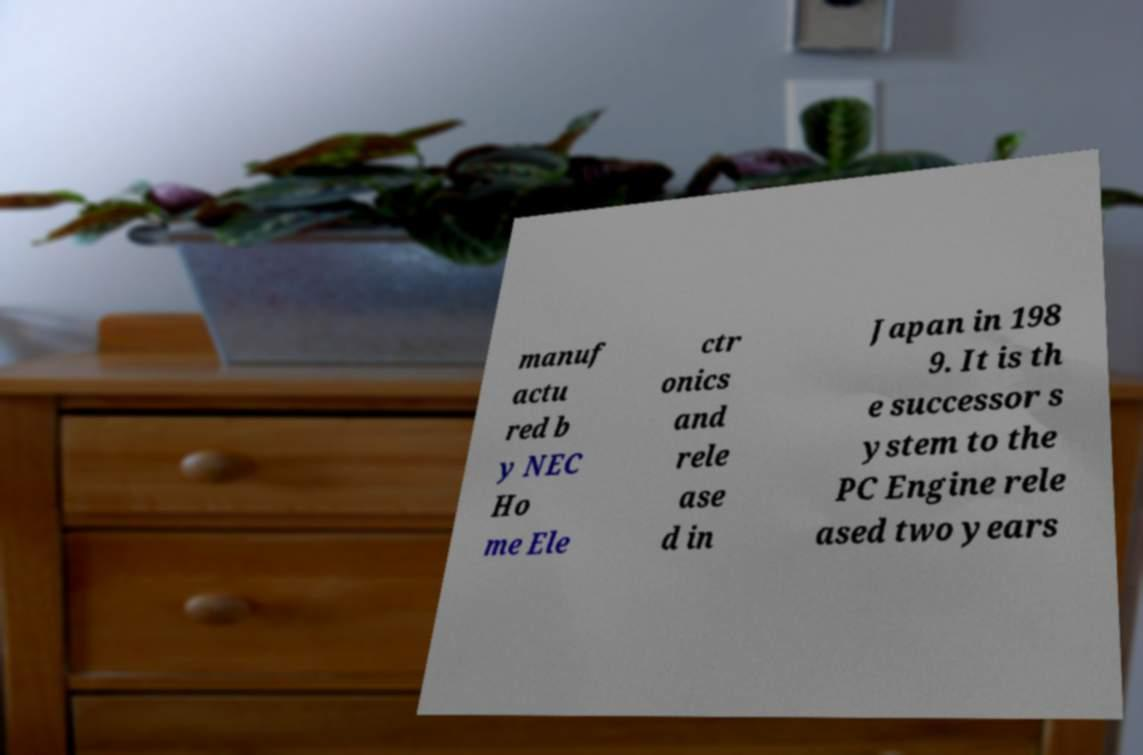Please identify and transcribe the text found in this image. manuf actu red b y NEC Ho me Ele ctr onics and rele ase d in Japan in 198 9. It is th e successor s ystem to the PC Engine rele ased two years 